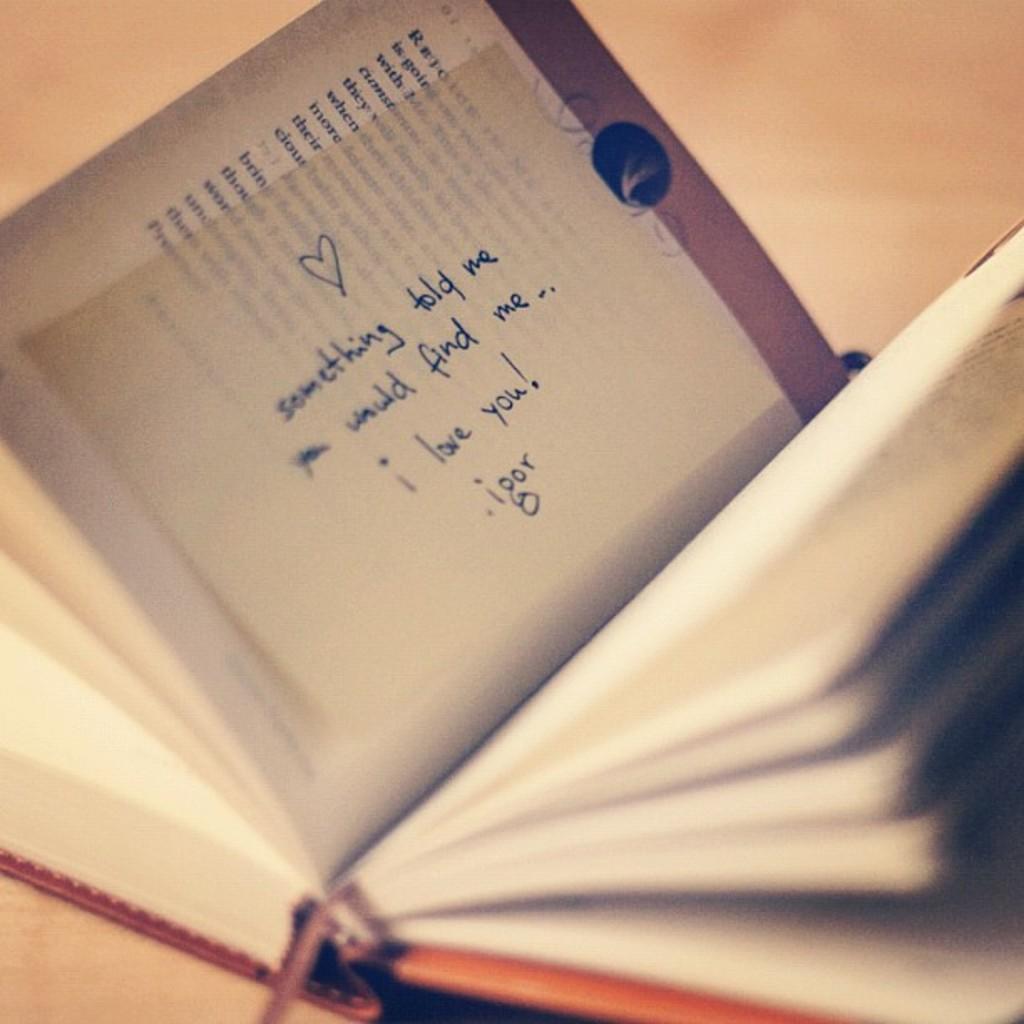Can you describe this image briefly? In this image, we can see a book and there is a stick notes on the page. 